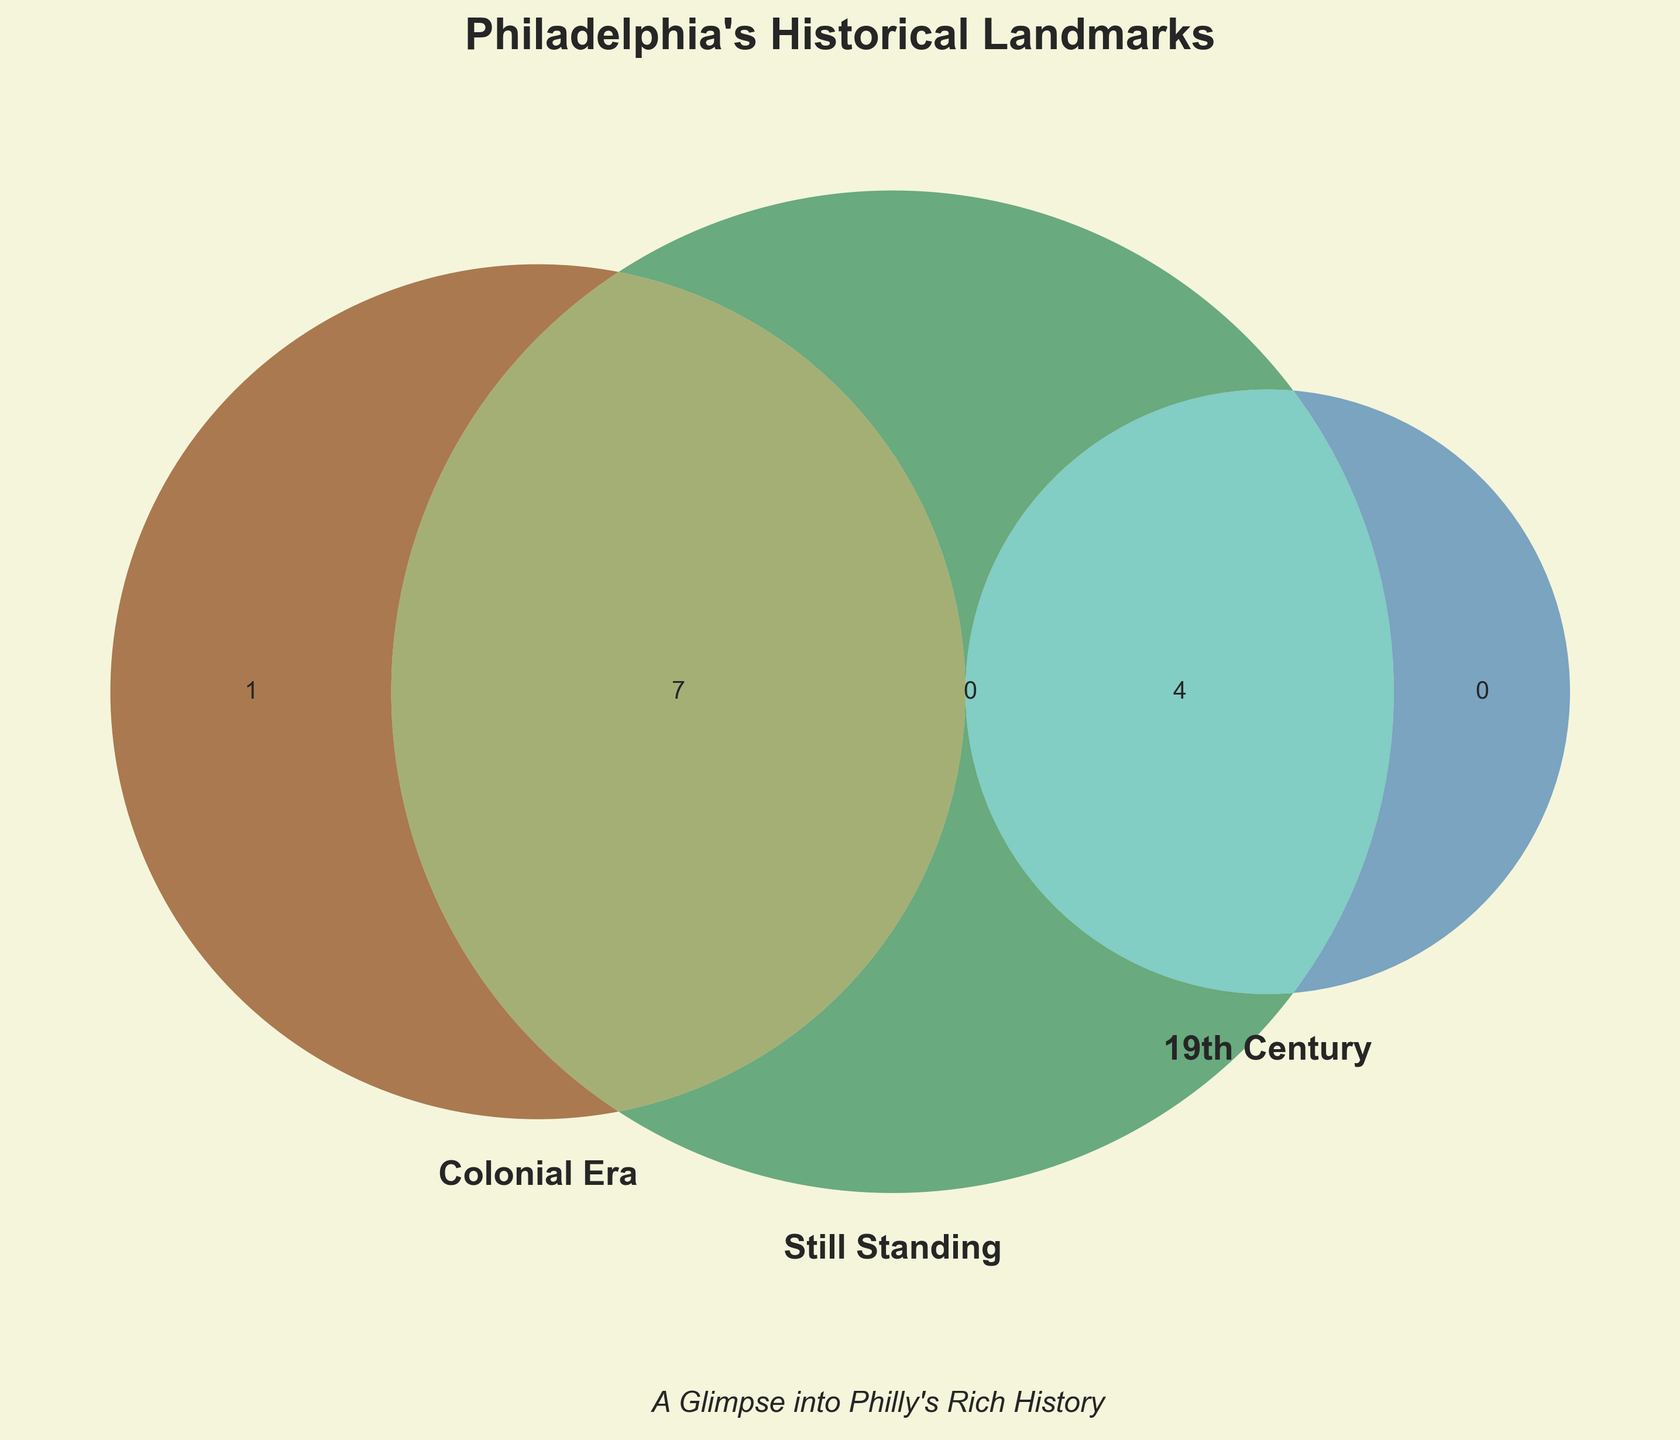How many landmarks are represented in each set category? Look at the figure and observe the number of landmarks in each of the three individual categories.
Answer: 4, 4, 10 Which landmarks belong to both the Colonial Era and are still standing? Check the intersection between the "Colonial Era" and "Still Standing" circles to see which landmarks are listed there.
Answer: Independence Hall, Elfreth's Alley, Christ Church, Carpenters' Hall, Betsy Ross House, Pennsylvania Hospital, Powel House Which landmarks from the 19th Century are still standing? Look at the intersection between the "19th Century" and "Still Standing" circles to identify the landmarks listed.
Answer: Eastern State Penitentiary, Philadelphia City Hall, Merchants' Exchange Building, Philadelphia Mint Which landmarks are only from the Colonial Era but not still standing? Check the area of the "Colonial Era" circle that does not overlap with the "Still Standing" circle.
Answer: Franklin Court Are there any landmarks that belong to all three categories: Colonial Era, 19th Century, and Still Standing? Examine the intersection of all three circles (Colonial Era, 19th Century, and Still Standing) to see if there are any landmarks listed.
Answer: None Which category has the most landmarks? Compare the number of landmarks in each of the three main circles.
Answer: Still Standing How many landmarks are either from the Colonial Era or the 19th Century without being still standing? Sum the landmarks in the "Colonial Era" and "19th Century" excluding those in the "Still Standing" section.
Answer: 1 